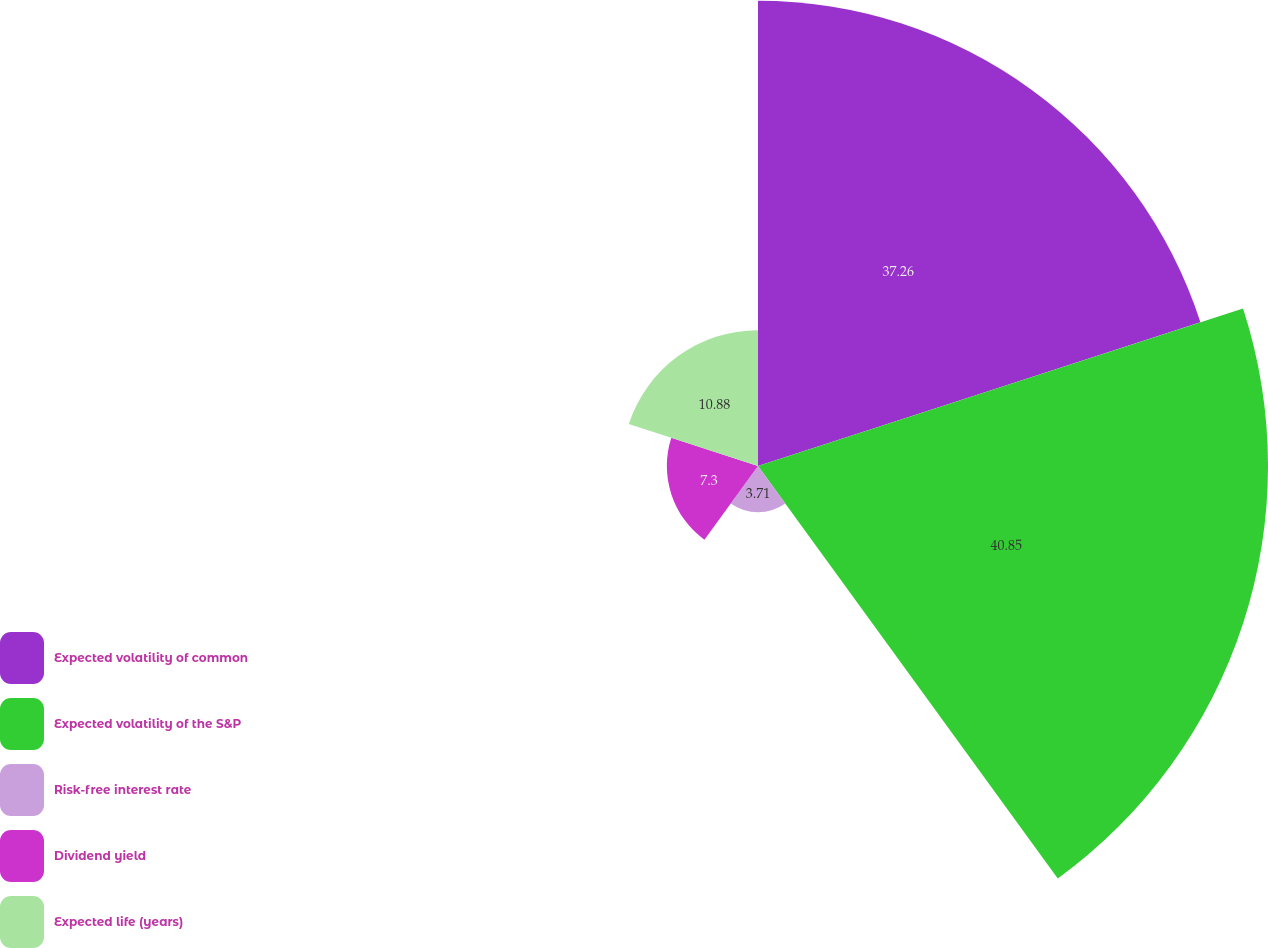Convert chart. <chart><loc_0><loc_0><loc_500><loc_500><pie_chart><fcel>Expected volatility of common<fcel>Expected volatility of the S&P<fcel>Risk-free interest rate<fcel>Dividend yield<fcel>Expected life (years)<nl><fcel>37.26%<fcel>40.85%<fcel>3.71%<fcel>7.3%<fcel>10.88%<nl></chart> 